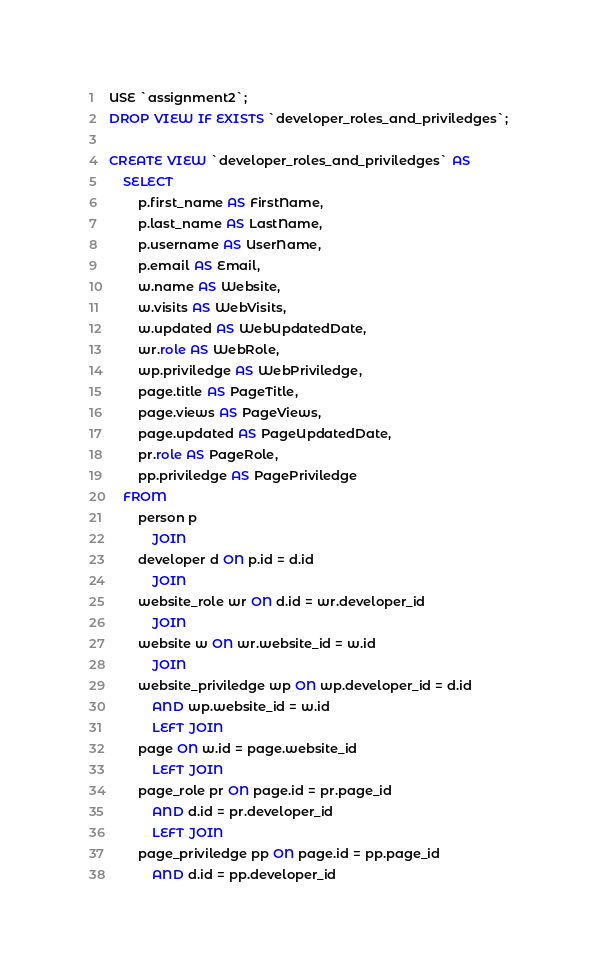Convert code to text. <code><loc_0><loc_0><loc_500><loc_500><_SQL_>USE `assignment2`;
DROP VIEW IF EXISTS `developer_roles_and_priviledges`;

CREATE VIEW `developer_roles_and_priviledges` AS
    SELECT 
        p.first_name AS FirstName,
        p.last_name AS LastName,
        p.username AS UserName,
        p.email AS Email,
        w.name AS Website,
        w.visits AS WebVisits,
        w.updated AS WebUpdatedDate,
        wr.role AS WebRole,
        wp.priviledge AS WebPriviledge,
        page.title AS PageTitle,
        page.views AS PageViews,
        page.updated AS PageUpdatedDate,
        pr.role AS PageRole,
        pp.priviledge AS PagePriviledge
    FROM
        person p
            JOIN
        developer d ON p.id = d.id
            JOIN
        website_role wr ON d.id = wr.developer_id
            JOIN
        website w ON wr.website_id = w.id
            JOIN
        website_priviledge wp ON wp.developer_id = d.id
            AND wp.website_id = w.id
            LEFT JOIN
        page ON w.id = page.website_id
            LEFT JOIN
        page_role pr ON page.id = pr.page_id
            AND d.id = pr.developer_id
            LEFT JOIN
        page_priviledge pp ON page.id = pp.page_id
            AND d.id = pp.developer_id
</code> 